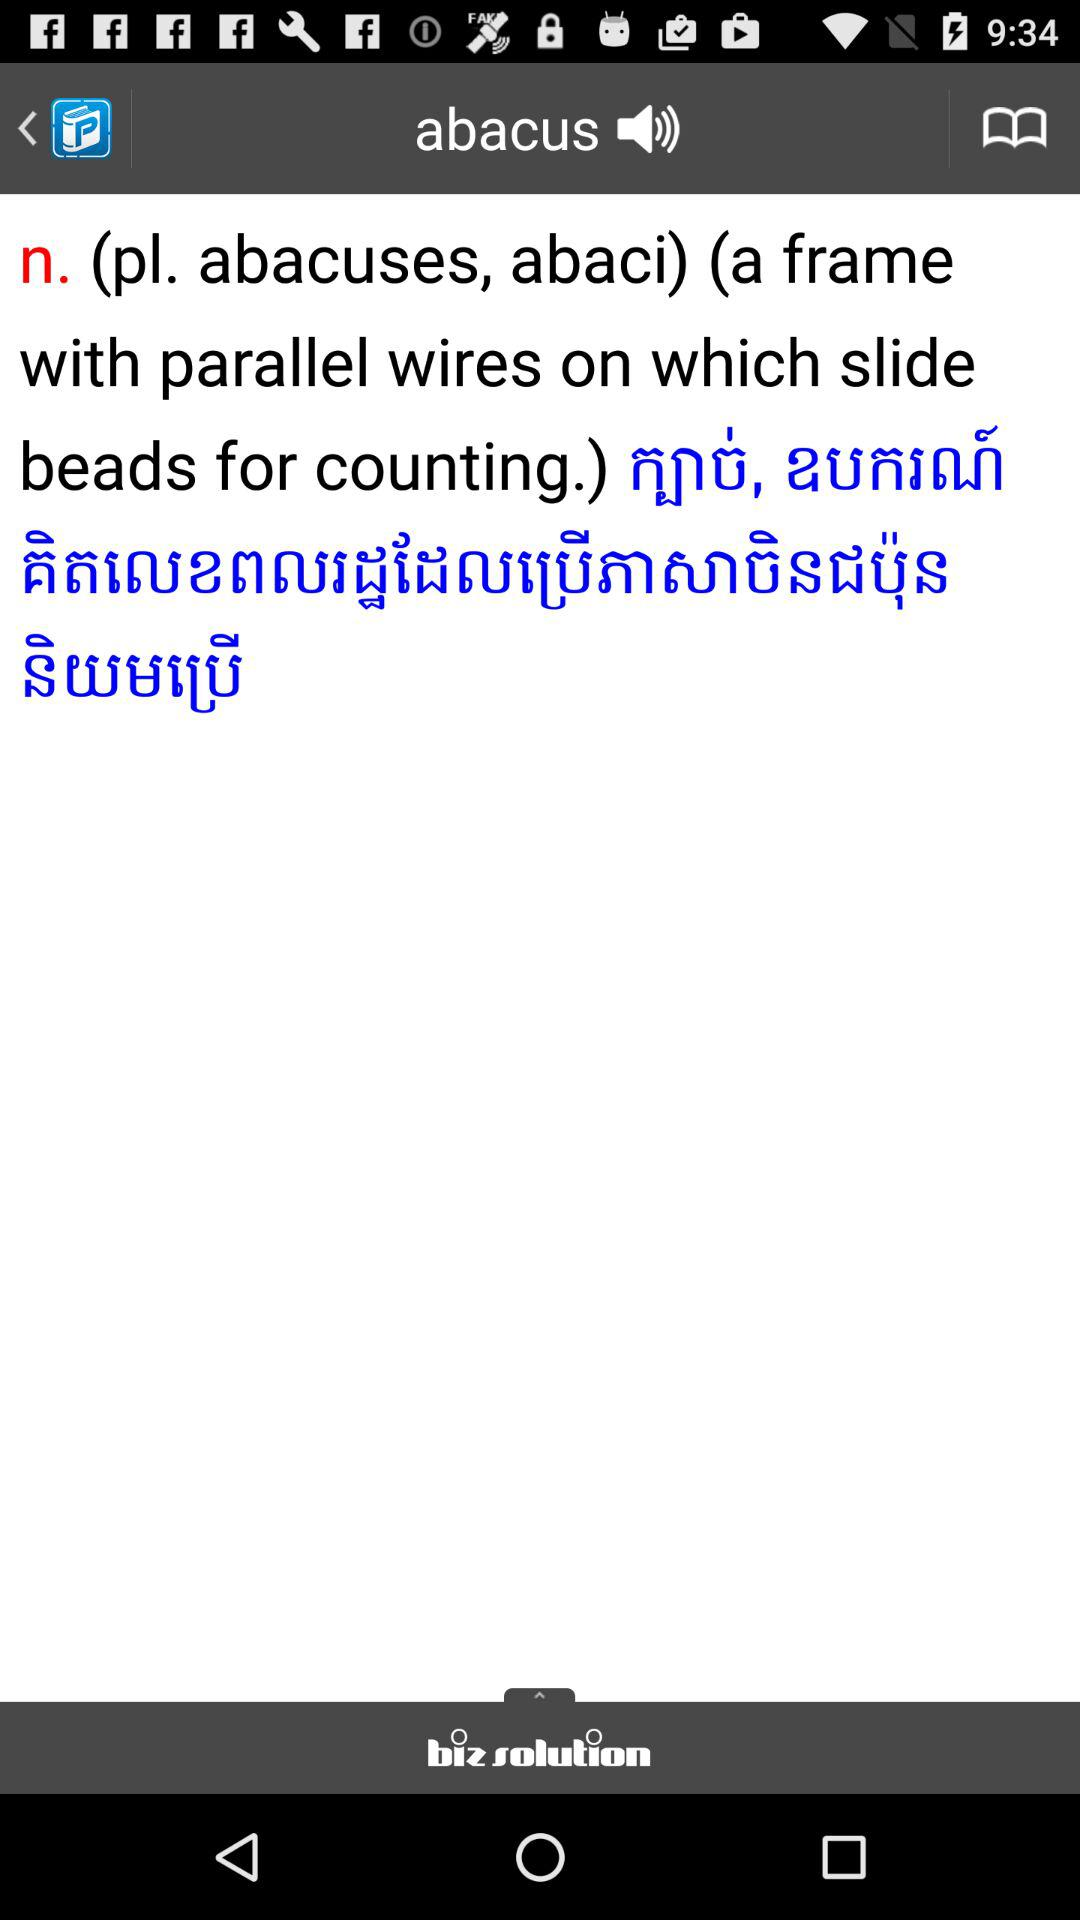Which word's meaning is displayed? The displayed word is "abacus". 